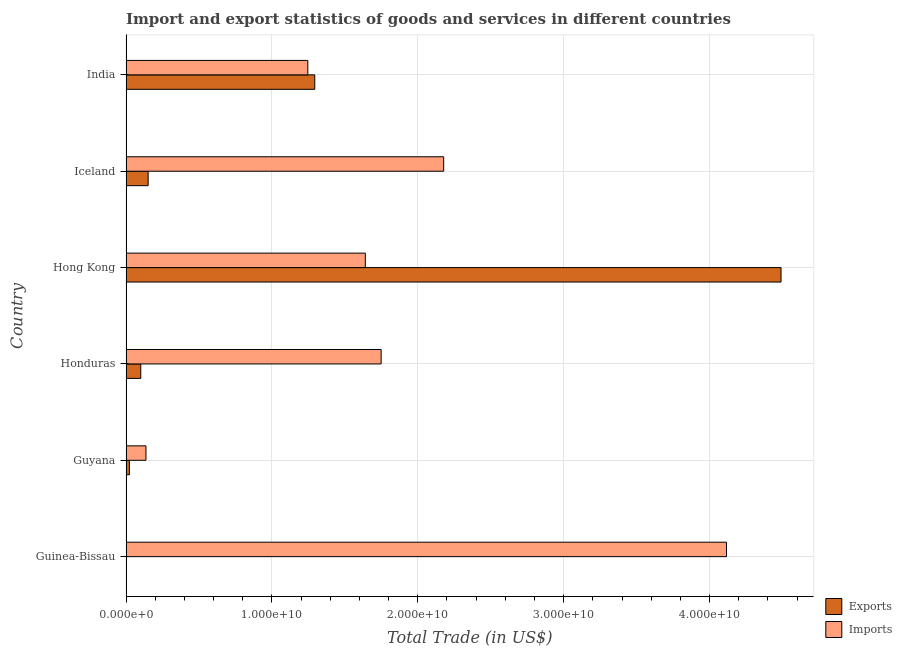How many groups of bars are there?
Offer a very short reply. 6. How many bars are there on the 4th tick from the top?
Your response must be concise. 2. What is the export of goods and services in Iceland?
Offer a terse response. 1.52e+09. Across all countries, what is the maximum export of goods and services?
Keep it short and to the point. 4.49e+1. Across all countries, what is the minimum imports of goods and services?
Ensure brevity in your answer.  1.37e+09. In which country was the imports of goods and services maximum?
Ensure brevity in your answer.  Guinea-Bissau. In which country was the imports of goods and services minimum?
Your response must be concise. Guyana. What is the total export of goods and services in the graph?
Provide a succinct answer. 6.06e+1. What is the difference between the export of goods and services in Guyana and that in Iceland?
Provide a succinct answer. -1.28e+09. What is the difference between the imports of goods and services in Hong Kong and the export of goods and services in India?
Your response must be concise. 3.46e+09. What is the average imports of goods and services per country?
Keep it short and to the point. 1.84e+1. What is the difference between the imports of goods and services and export of goods and services in Iceland?
Provide a short and direct response. 2.03e+1. What is the ratio of the export of goods and services in Guinea-Bissau to that in Iceland?
Give a very brief answer. 0. Is the difference between the imports of goods and services in Honduras and Hong Kong greater than the difference between the export of goods and services in Honduras and Hong Kong?
Your response must be concise. Yes. What is the difference between the highest and the second highest imports of goods and services?
Make the answer very short. 1.94e+1. What is the difference between the highest and the lowest export of goods and services?
Provide a short and direct response. 4.49e+1. Is the sum of the imports of goods and services in Guinea-Bissau and Guyana greater than the maximum export of goods and services across all countries?
Offer a terse response. No. What does the 1st bar from the top in Guyana represents?
Offer a very short reply. Imports. What does the 1st bar from the bottom in India represents?
Give a very brief answer. Exports. How many bars are there?
Your answer should be compact. 12. What is the difference between two consecutive major ticks on the X-axis?
Keep it short and to the point. 1.00e+1. Are the values on the major ticks of X-axis written in scientific E-notation?
Your answer should be compact. Yes. Where does the legend appear in the graph?
Ensure brevity in your answer.  Bottom right. What is the title of the graph?
Make the answer very short. Import and export statistics of goods and services in different countries. Does "Public credit registry" appear as one of the legend labels in the graph?
Provide a short and direct response. No. What is the label or title of the X-axis?
Give a very brief answer. Total Trade (in US$). What is the label or title of the Y-axis?
Give a very brief answer. Country. What is the Total Trade (in US$) in Exports in Guinea-Bissau?
Give a very brief answer. 6.82e+06. What is the Total Trade (in US$) of Imports in Guinea-Bissau?
Offer a very short reply. 4.12e+1. What is the Total Trade (in US$) of Exports in Guyana?
Your answer should be very brief. 2.34e+08. What is the Total Trade (in US$) of Imports in Guyana?
Make the answer very short. 1.37e+09. What is the Total Trade (in US$) of Exports in Honduras?
Keep it short and to the point. 1.01e+09. What is the Total Trade (in US$) in Imports in Honduras?
Your answer should be very brief. 1.75e+1. What is the Total Trade (in US$) in Exports in Hong Kong?
Make the answer very short. 4.49e+1. What is the Total Trade (in US$) in Imports in Hong Kong?
Ensure brevity in your answer.  1.64e+1. What is the Total Trade (in US$) in Exports in Iceland?
Provide a short and direct response. 1.52e+09. What is the Total Trade (in US$) in Imports in Iceland?
Your response must be concise. 2.18e+1. What is the Total Trade (in US$) in Exports in India?
Your answer should be very brief. 1.29e+1. What is the Total Trade (in US$) in Imports in India?
Your response must be concise. 1.25e+1. Across all countries, what is the maximum Total Trade (in US$) of Exports?
Provide a succinct answer. 4.49e+1. Across all countries, what is the maximum Total Trade (in US$) of Imports?
Offer a terse response. 4.12e+1. Across all countries, what is the minimum Total Trade (in US$) in Exports?
Offer a very short reply. 6.82e+06. Across all countries, what is the minimum Total Trade (in US$) in Imports?
Offer a very short reply. 1.37e+09. What is the total Total Trade (in US$) of Exports in the graph?
Your answer should be compact. 6.06e+1. What is the total Total Trade (in US$) in Imports in the graph?
Provide a short and direct response. 1.11e+11. What is the difference between the Total Trade (in US$) of Exports in Guinea-Bissau and that in Guyana?
Keep it short and to the point. -2.27e+08. What is the difference between the Total Trade (in US$) in Imports in Guinea-Bissau and that in Guyana?
Ensure brevity in your answer.  3.98e+1. What is the difference between the Total Trade (in US$) in Exports in Guinea-Bissau and that in Honduras?
Give a very brief answer. -1.01e+09. What is the difference between the Total Trade (in US$) in Imports in Guinea-Bissau and that in Honduras?
Your answer should be compact. 2.37e+1. What is the difference between the Total Trade (in US$) in Exports in Guinea-Bissau and that in Hong Kong?
Give a very brief answer. -4.49e+1. What is the difference between the Total Trade (in US$) in Imports in Guinea-Bissau and that in Hong Kong?
Your answer should be compact. 2.48e+1. What is the difference between the Total Trade (in US$) of Exports in Guinea-Bissau and that in Iceland?
Provide a succinct answer. -1.51e+09. What is the difference between the Total Trade (in US$) in Imports in Guinea-Bissau and that in Iceland?
Offer a terse response. 1.94e+1. What is the difference between the Total Trade (in US$) in Exports in Guinea-Bissau and that in India?
Your answer should be compact. -1.29e+1. What is the difference between the Total Trade (in US$) of Imports in Guinea-Bissau and that in India?
Your answer should be very brief. 2.87e+1. What is the difference between the Total Trade (in US$) of Exports in Guyana and that in Honduras?
Keep it short and to the point. -7.79e+08. What is the difference between the Total Trade (in US$) of Imports in Guyana and that in Honduras?
Offer a terse response. -1.61e+1. What is the difference between the Total Trade (in US$) in Exports in Guyana and that in Hong Kong?
Your answer should be compact. -4.47e+1. What is the difference between the Total Trade (in US$) in Imports in Guyana and that in Hong Kong?
Give a very brief answer. -1.50e+1. What is the difference between the Total Trade (in US$) of Exports in Guyana and that in Iceland?
Offer a terse response. -1.28e+09. What is the difference between the Total Trade (in US$) in Imports in Guyana and that in Iceland?
Offer a very short reply. -2.04e+1. What is the difference between the Total Trade (in US$) of Exports in Guyana and that in India?
Your response must be concise. -1.27e+1. What is the difference between the Total Trade (in US$) in Imports in Guyana and that in India?
Provide a succinct answer. -1.11e+1. What is the difference between the Total Trade (in US$) of Exports in Honduras and that in Hong Kong?
Offer a very short reply. -4.39e+1. What is the difference between the Total Trade (in US$) in Imports in Honduras and that in Hong Kong?
Ensure brevity in your answer.  1.08e+09. What is the difference between the Total Trade (in US$) of Exports in Honduras and that in Iceland?
Provide a succinct answer. -5.04e+08. What is the difference between the Total Trade (in US$) in Imports in Honduras and that in Iceland?
Keep it short and to the point. -4.29e+09. What is the difference between the Total Trade (in US$) of Exports in Honduras and that in India?
Provide a succinct answer. -1.19e+1. What is the difference between the Total Trade (in US$) in Imports in Honduras and that in India?
Keep it short and to the point. 5.03e+09. What is the difference between the Total Trade (in US$) in Exports in Hong Kong and that in Iceland?
Offer a terse response. 4.34e+1. What is the difference between the Total Trade (in US$) in Imports in Hong Kong and that in Iceland?
Provide a succinct answer. -5.37e+09. What is the difference between the Total Trade (in US$) of Exports in Hong Kong and that in India?
Keep it short and to the point. 3.20e+1. What is the difference between the Total Trade (in US$) in Imports in Hong Kong and that in India?
Your answer should be very brief. 3.94e+09. What is the difference between the Total Trade (in US$) in Exports in Iceland and that in India?
Offer a very short reply. -1.14e+1. What is the difference between the Total Trade (in US$) in Imports in Iceland and that in India?
Provide a succinct answer. 9.31e+09. What is the difference between the Total Trade (in US$) of Exports in Guinea-Bissau and the Total Trade (in US$) of Imports in Guyana?
Offer a terse response. -1.36e+09. What is the difference between the Total Trade (in US$) of Exports in Guinea-Bissau and the Total Trade (in US$) of Imports in Honduras?
Give a very brief answer. -1.75e+1. What is the difference between the Total Trade (in US$) of Exports in Guinea-Bissau and the Total Trade (in US$) of Imports in Hong Kong?
Your answer should be compact. -1.64e+1. What is the difference between the Total Trade (in US$) of Exports in Guinea-Bissau and the Total Trade (in US$) of Imports in Iceland?
Offer a terse response. -2.18e+1. What is the difference between the Total Trade (in US$) in Exports in Guinea-Bissau and the Total Trade (in US$) in Imports in India?
Give a very brief answer. -1.25e+1. What is the difference between the Total Trade (in US$) in Exports in Guyana and the Total Trade (in US$) in Imports in Honduras?
Give a very brief answer. -1.73e+1. What is the difference between the Total Trade (in US$) of Exports in Guyana and the Total Trade (in US$) of Imports in Hong Kong?
Offer a very short reply. -1.62e+1. What is the difference between the Total Trade (in US$) in Exports in Guyana and the Total Trade (in US$) in Imports in Iceland?
Give a very brief answer. -2.15e+1. What is the difference between the Total Trade (in US$) in Exports in Guyana and the Total Trade (in US$) in Imports in India?
Your response must be concise. -1.22e+1. What is the difference between the Total Trade (in US$) of Exports in Honduras and the Total Trade (in US$) of Imports in Hong Kong?
Your answer should be very brief. -1.54e+1. What is the difference between the Total Trade (in US$) in Exports in Honduras and the Total Trade (in US$) in Imports in Iceland?
Your answer should be compact. -2.08e+1. What is the difference between the Total Trade (in US$) of Exports in Honduras and the Total Trade (in US$) of Imports in India?
Your answer should be very brief. -1.14e+1. What is the difference between the Total Trade (in US$) in Exports in Hong Kong and the Total Trade (in US$) in Imports in Iceland?
Offer a very short reply. 2.31e+1. What is the difference between the Total Trade (in US$) in Exports in Hong Kong and the Total Trade (in US$) in Imports in India?
Give a very brief answer. 3.24e+1. What is the difference between the Total Trade (in US$) in Exports in Iceland and the Total Trade (in US$) in Imports in India?
Make the answer very short. -1.09e+1. What is the average Total Trade (in US$) in Exports per country?
Your response must be concise. 1.01e+1. What is the average Total Trade (in US$) in Imports per country?
Your answer should be compact. 1.84e+1. What is the difference between the Total Trade (in US$) in Exports and Total Trade (in US$) in Imports in Guinea-Bissau?
Your answer should be very brief. -4.12e+1. What is the difference between the Total Trade (in US$) in Exports and Total Trade (in US$) in Imports in Guyana?
Provide a succinct answer. -1.13e+09. What is the difference between the Total Trade (in US$) in Exports and Total Trade (in US$) in Imports in Honduras?
Offer a terse response. -1.65e+1. What is the difference between the Total Trade (in US$) in Exports and Total Trade (in US$) in Imports in Hong Kong?
Offer a very short reply. 2.85e+1. What is the difference between the Total Trade (in US$) of Exports and Total Trade (in US$) of Imports in Iceland?
Your response must be concise. -2.03e+1. What is the difference between the Total Trade (in US$) in Exports and Total Trade (in US$) in Imports in India?
Offer a very short reply. 4.77e+08. What is the ratio of the Total Trade (in US$) of Exports in Guinea-Bissau to that in Guyana?
Offer a terse response. 0.03. What is the ratio of the Total Trade (in US$) of Imports in Guinea-Bissau to that in Guyana?
Your answer should be compact. 30.11. What is the ratio of the Total Trade (in US$) in Exports in Guinea-Bissau to that in Honduras?
Give a very brief answer. 0.01. What is the ratio of the Total Trade (in US$) of Imports in Guinea-Bissau to that in Honduras?
Your response must be concise. 2.35. What is the ratio of the Total Trade (in US$) of Imports in Guinea-Bissau to that in Hong Kong?
Give a very brief answer. 2.51. What is the ratio of the Total Trade (in US$) in Exports in Guinea-Bissau to that in Iceland?
Offer a terse response. 0. What is the ratio of the Total Trade (in US$) in Imports in Guinea-Bissau to that in Iceland?
Offer a very short reply. 1.89. What is the ratio of the Total Trade (in US$) in Exports in Guinea-Bissau to that in India?
Provide a short and direct response. 0. What is the ratio of the Total Trade (in US$) of Imports in Guinea-Bissau to that in India?
Keep it short and to the point. 3.3. What is the ratio of the Total Trade (in US$) in Exports in Guyana to that in Honduras?
Ensure brevity in your answer.  0.23. What is the ratio of the Total Trade (in US$) of Imports in Guyana to that in Honduras?
Your response must be concise. 0.08. What is the ratio of the Total Trade (in US$) of Exports in Guyana to that in Hong Kong?
Provide a succinct answer. 0.01. What is the ratio of the Total Trade (in US$) in Imports in Guyana to that in Hong Kong?
Provide a short and direct response. 0.08. What is the ratio of the Total Trade (in US$) of Exports in Guyana to that in Iceland?
Provide a succinct answer. 0.15. What is the ratio of the Total Trade (in US$) in Imports in Guyana to that in Iceland?
Offer a terse response. 0.06. What is the ratio of the Total Trade (in US$) of Exports in Guyana to that in India?
Your answer should be very brief. 0.02. What is the ratio of the Total Trade (in US$) in Imports in Guyana to that in India?
Your answer should be very brief. 0.11. What is the ratio of the Total Trade (in US$) of Exports in Honduras to that in Hong Kong?
Give a very brief answer. 0.02. What is the ratio of the Total Trade (in US$) in Imports in Honduras to that in Hong Kong?
Your answer should be very brief. 1.07. What is the ratio of the Total Trade (in US$) in Exports in Honduras to that in Iceland?
Your answer should be compact. 0.67. What is the ratio of the Total Trade (in US$) of Imports in Honduras to that in Iceland?
Your answer should be compact. 0.8. What is the ratio of the Total Trade (in US$) of Exports in Honduras to that in India?
Provide a succinct answer. 0.08. What is the ratio of the Total Trade (in US$) in Imports in Honduras to that in India?
Keep it short and to the point. 1.4. What is the ratio of the Total Trade (in US$) of Exports in Hong Kong to that in Iceland?
Provide a succinct answer. 29.6. What is the ratio of the Total Trade (in US$) of Imports in Hong Kong to that in Iceland?
Provide a short and direct response. 0.75. What is the ratio of the Total Trade (in US$) of Exports in Hong Kong to that in India?
Offer a terse response. 3.47. What is the ratio of the Total Trade (in US$) in Imports in Hong Kong to that in India?
Provide a short and direct response. 1.32. What is the ratio of the Total Trade (in US$) in Exports in Iceland to that in India?
Give a very brief answer. 0.12. What is the ratio of the Total Trade (in US$) of Imports in Iceland to that in India?
Your answer should be compact. 1.75. What is the difference between the highest and the second highest Total Trade (in US$) of Exports?
Your answer should be very brief. 3.20e+1. What is the difference between the highest and the second highest Total Trade (in US$) in Imports?
Give a very brief answer. 1.94e+1. What is the difference between the highest and the lowest Total Trade (in US$) of Exports?
Offer a terse response. 4.49e+1. What is the difference between the highest and the lowest Total Trade (in US$) of Imports?
Keep it short and to the point. 3.98e+1. 